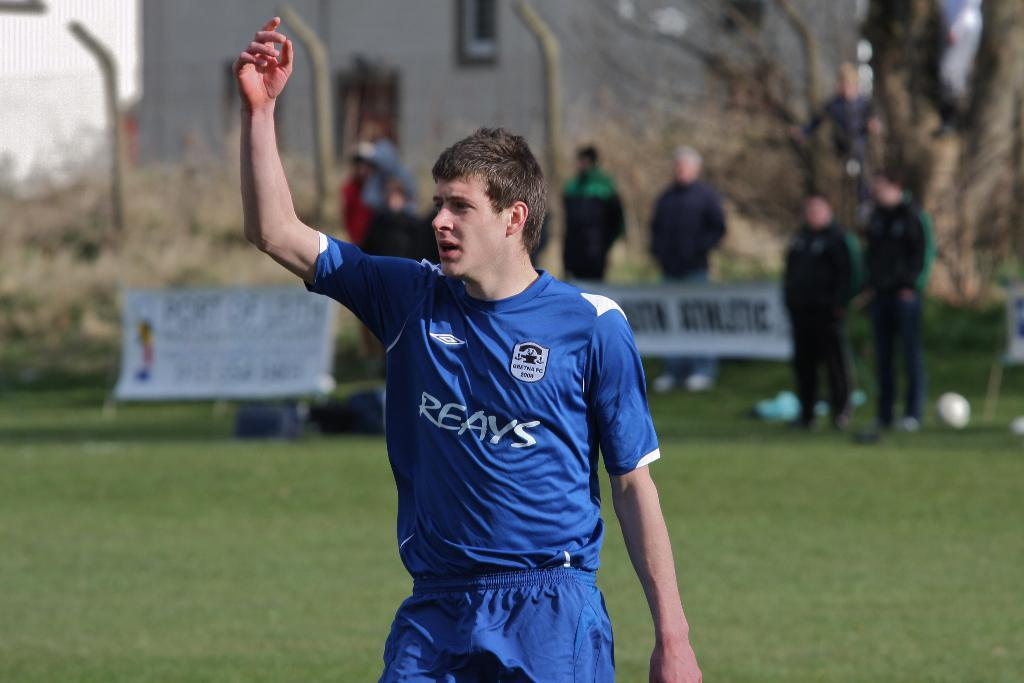Provide a one-sentence caption for the provided image. A soccer player in a Reays jersey raises his hand. 